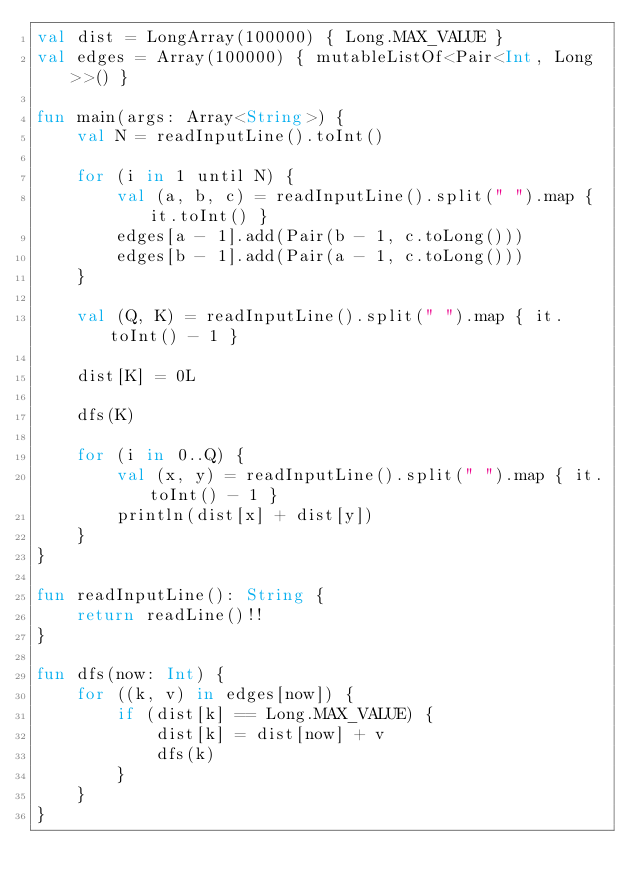Convert code to text. <code><loc_0><loc_0><loc_500><loc_500><_Kotlin_>val dist = LongArray(100000) { Long.MAX_VALUE }
val edges = Array(100000) { mutableListOf<Pair<Int, Long>>() }

fun main(args: Array<String>) {
    val N = readInputLine().toInt()

    for (i in 1 until N) {
        val (a, b, c) = readInputLine().split(" ").map { it.toInt() }
        edges[a - 1].add(Pair(b - 1, c.toLong()))
        edges[b - 1].add(Pair(a - 1, c.toLong()))
    }
    
    val (Q, K) = readInputLine().split(" ").map { it.toInt() - 1 }

    dist[K] = 0L

    dfs(K)

    for (i in 0..Q) {
        val (x, y) = readInputLine().split(" ").map { it.toInt() - 1 }
        println(dist[x] + dist[y])
    }
}

fun readInputLine(): String {
    return readLine()!!
}

fun dfs(now: Int) {
    for ((k, v) in edges[now]) {
        if (dist[k] == Long.MAX_VALUE) {
            dist[k] = dist[now] + v
            dfs(k)
        }
    }
}
</code> 